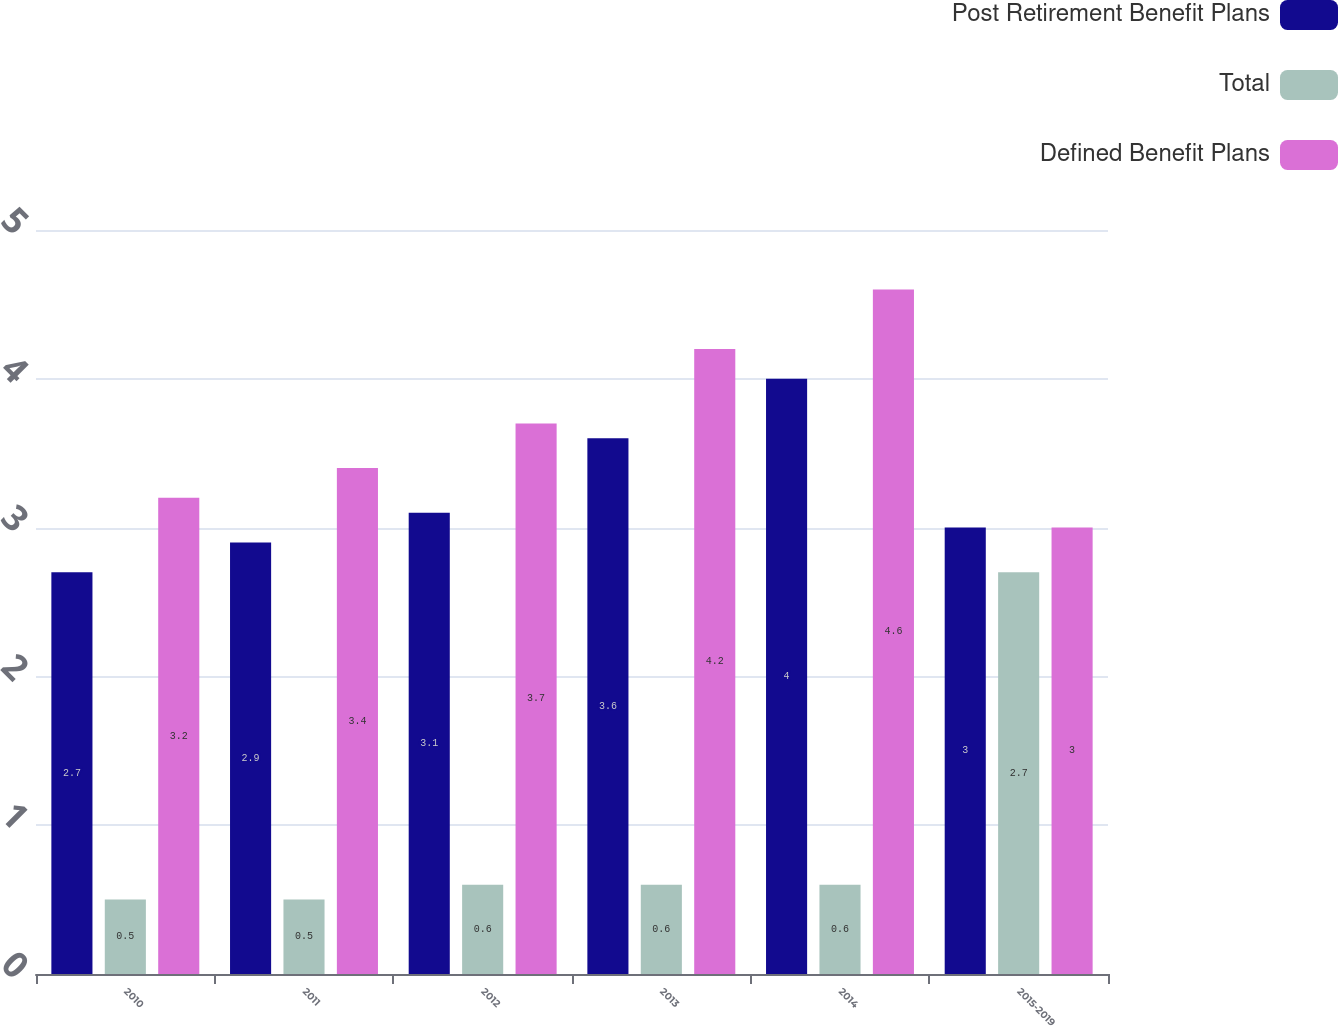Convert chart to OTSL. <chart><loc_0><loc_0><loc_500><loc_500><stacked_bar_chart><ecel><fcel>2010<fcel>2011<fcel>2012<fcel>2013<fcel>2014<fcel>2015-2019<nl><fcel>Post Retirement Benefit Plans<fcel>2.7<fcel>2.9<fcel>3.1<fcel>3.6<fcel>4<fcel>3<nl><fcel>Total<fcel>0.5<fcel>0.5<fcel>0.6<fcel>0.6<fcel>0.6<fcel>2.7<nl><fcel>Defined Benefit Plans<fcel>3.2<fcel>3.4<fcel>3.7<fcel>4.2<fcel>4.6<fcel>3<nl></chart> 